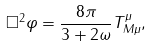<formula> <loc_0><loc_0><loc_500><loc_500>\square ^ { 2 } \varphi = \frac { 8 \pi } { 3 + 2 \omega } T _ { M \mu } ^ { \mu } ,</formula> 